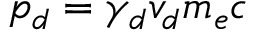Convert formula to latex. <formula><loc_0><loc_0><loc_500><loc_500>p _ { d } = \gamma _ { d } v _ { d } m _ { e } c</formula> 